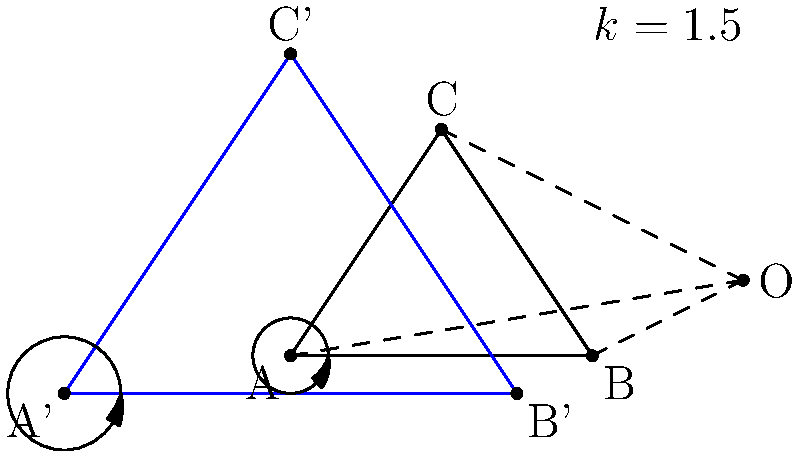In the figure above, triangle ABC undergoes a dilation transformation with center O and scale factor k = 1.5, resulting in triangle A'B'C'. Consider angle BAC in the original triangle and its corresponding angle B'A'C' in the dilated triangle. What can you conclude about these angles, and how does this relate to the general properties of dilation transformations? Let's approach this step-by-step:

1) In a dilation transformation, the image is a scaled version of the original figure, with the scale factor determining the size change.

2) The dilation center O is the fixed point from which all points are "pushed" outward (for k > 1) or "pulled" inward (for 0 < k < 1).

3) Importantly, dilation preserves the shape of the original figure. This means that corresponding angles in the original and dilated figures are congruent.

4) To understand why this is true, consider the following:
   a) Dilation maps straight lines to straight lines.
   b) The ratio of any two line segments is preserved in the dilated image.

5) For angle BAC and its image B'A'C':
   - Line BA maps to B'A'
   - Line AC maps to A'C'
   - The angle between these lines (BAC) remains unchanged in the dilation

6) Mathematically, if we consider vectors $\vec{BA}$ and $\vec{AC}$, the dilation transforms these to $k\vec{BA}$ and $k\vec{AC}$ respectively. The scalar k doesn't affect the angle between these vectors.

7) This property holds true for all angles in the figure, not just angle BAC.

8) In the context of transformational geometry, this angle preservation is a crucial property that distinguishes dilation from other transformations like rotation or shear.
Answer: Angle BAC is congruent to angle B'A'C'; dilation preserves angles. 